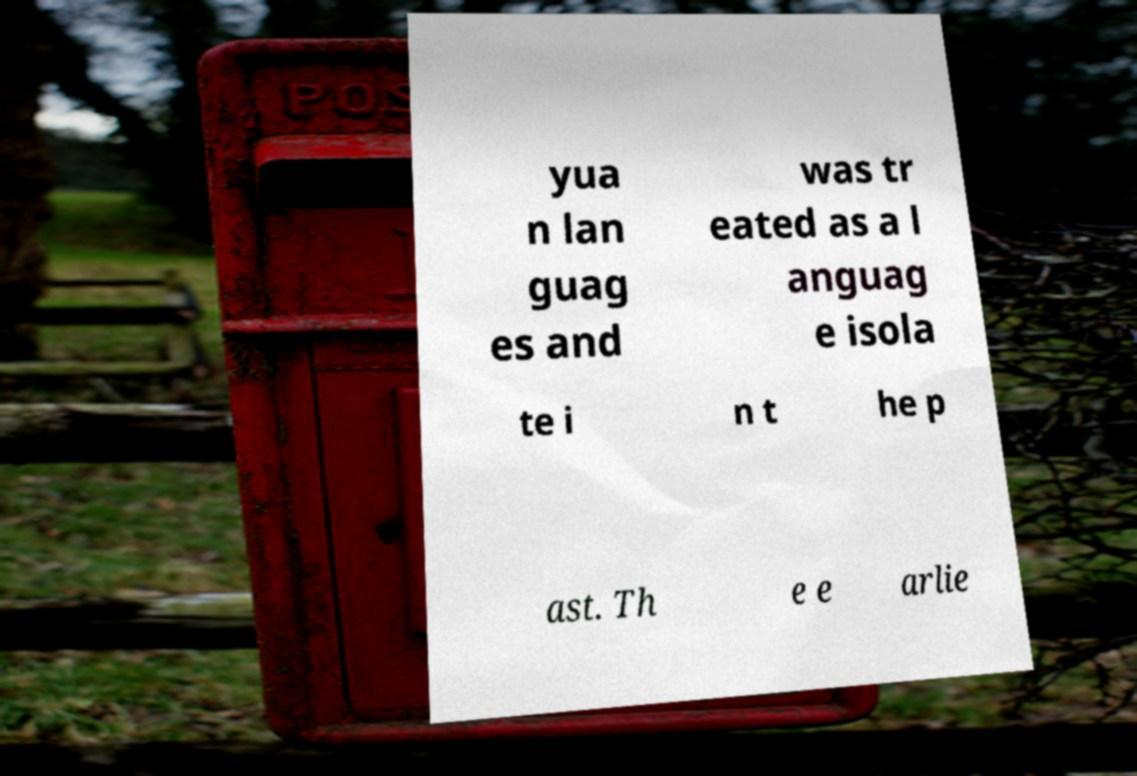Could you assist in decoding the text presented in this image and type it out clearly? yua n lan guag es and was tr eated as a l anguag e isola te i n t he p ast. Th e e arlie 